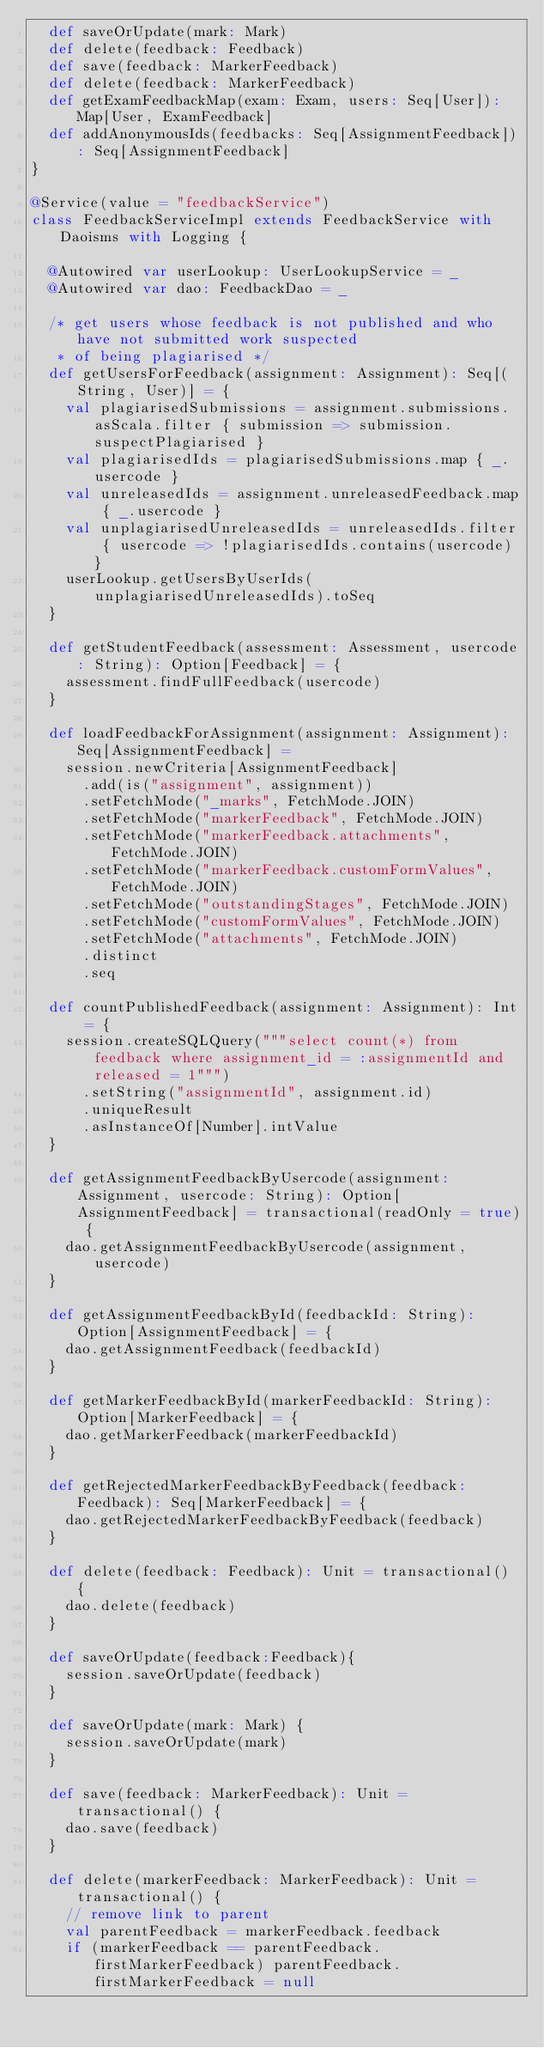Convert code to text. <code><loc_0><loc_0><loc_500><loc_500><_Scala_>	def saveOrUpdate(mark: Mark)
	def delete(feedback: Feedback)
	def save(feedback: MarkerFeedback)
	def delete(feedback: MarkerFeedback)
	def getExamFeedbackMap(exam: Exam, users: Seq[User]): Map[User, ExamFeedback]
	def addAnonymousIds(feedbacks: Seq[AssignmentFeedback]): Seq[AssignmentFeedback]
}

@Service(value = "feedbackService")
class FeedbackServiceImpl extends FeedbackService with Daoisms with Logging {

	@Autowired var userLookup: UserLookupService = _
	@Autowired var dao: FeedbackDao = _

	/* get users whose feedback is not published and who have not submitted work suspected
	 * of being plagiarised */
	def getUsersForFeedback(assignment: Assignment): Seq[(String, User)] = {
		val plagiarisedSubmissions = assignment.submissions.asScala.filter { submission => submission.suspectPlagiarised }
		val plagiarisedIds = plagiarisedSubmissions.map { _.usercode }
		val unreleasedIds = assignment.unreleasedFeedback.map { _.usercode }
		val unplagiarisedUnreleasedIds = unreleasedIds.filter { usercode => !plagiarisedIds.contains(usercode) }
		userLookup.getUsersByUserIds(unplagiarisedUnreleasedIds).toSeq
	}

	def getStudentFeedback(assessment: Assessment, usercode: String): Option[Feedback] = {
		assessment.findFullFeedback(usercode)
	}

	def loadFeedbackForAssignment(assignment: Assignment): Seq[AssignmentFeedback] =
		session.newCriteria[AssignmentFeedback]
  		.add(is("assignment", assignment))
			.setFetchMode("_marks", FetchMode.JOIN)
			.setFetchMode("markerFeedback", FetchMode.JOIN)
			.setFetchMode("markerFeedback.attachments", FetchMode.JOIN)
			.setFetchMode("markerFeedback.customFormValues", FetchMode.JOIN)
			.setFetchMode("outstandingStages", FetchMode.JOIN)
			.setFetchMode("customFormValues", FetchMode.JOIN)
			.setFetchMode("attachments", FetchMode.JOIN)
			.distinct
  		.seq

	def countPublishedFeedback(assignment: Assignment): Int = {
		session.createSQLQuery("""select count(*) from feedback where assignment_id = :assignmentId and released = 1""")
			.setString("assignmentId", assignment.id)
			.uniqueResult
			.asInstanceOf[Number].intValue
	}

	def getAssignmentFeedbackByUsercode(assignment: Assignment, usercode: String): Option[AssignmentFeedback] = transactional(readOnly = true) {
		dao.getAssignmentFeedbackByUsercode(assignment, usercode)
	}

	def getAssignmentFeedbackById(feedbackId: String): Option[AssignmentFeedback] = {
		dao.getAssignmentFeedback(feedbackId)
	}

	def getMarkerFeedbackById(markerFeedbackId: String): Option[MarkerFeedback] = {
		dao.getMarkerFeedback(markerFeedbackId)
	}

	def getRejectedMarkerFeedbackByFeedback(feedback: Feedback): Seq[MarkerFeedback] = {
		dao.getRejectedMarkerFeedbackByFeedback(feedback)
	}

	def delete(feedback: Feedback): Unit = transactional() {
		dao.delete(feedback)
	}

	def saveOrUpdate(feedback:Feedback){
		session.saveOrUpdate(feedback)
	}

	def saveOrUpdate(mark: Mark) {
		session.saveOrUpdate(mark)
	}

	def save(feedback: MarkerFeedback): Unit = transactional() {
		dao.save(feedback)
	}

	def delete(markerFeedback: MarkerFeedback): Unit = transactional() {
		// remove link to parent
		val parentFeedback = markerFeedback.feedback
		if (markerFeedback == parentFeedback.firstMarkerFeedback) parentFeedback.firstMarkerFeedback = null</code> 